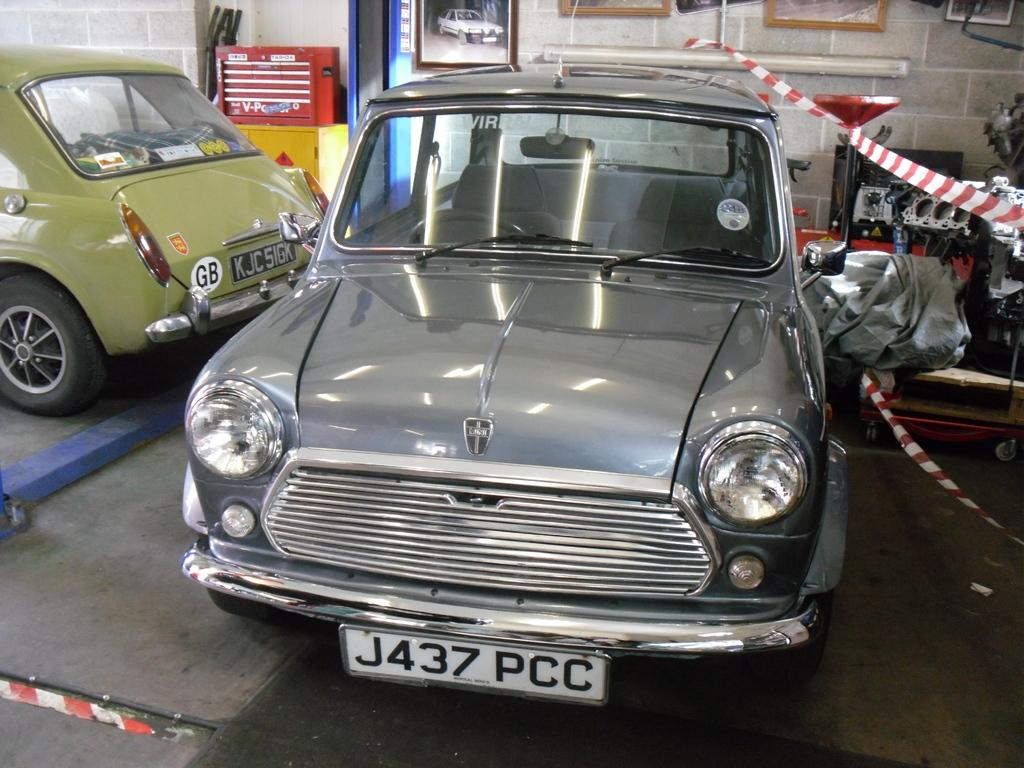What type of objects are on the floor in the image? There are motor vehicles on the floor. What can be seen on the wall in the image? Wall hangings are attached to the wall. What kind of equipment is visible in the image? There are machines in the image. What type of storage furniture is present in the image? Cabinets are present in the image. Can you tell me how many turkeys are depicted in the image? There are no turkeys present in the image. What is the purpose of the pail in the image? There is no pail present in the image, so its purpose cannot be determined. 